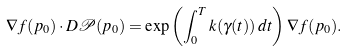<formula> <loc_0><loc_0><loc_500><loc_500>\nabla f ( p _ { 0 } ) \cdot D \mathcal { P } ( p _ { 0 } ) = \exp \left ( \int _ { 0 } ^ { T } k ( \gamma ( t ) ) \, d t \right ) \nabla f ( p _ { 0 } ) .</formula> 